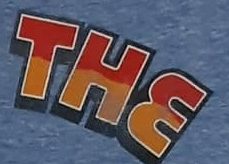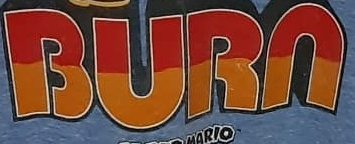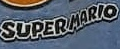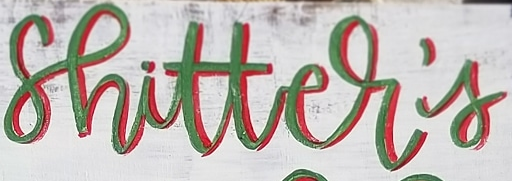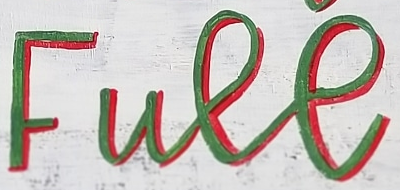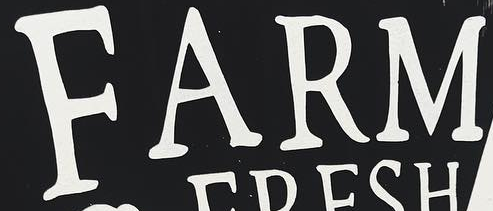Identify the words shown in these images in order, separated by a semicolon. THE; BURN; SUPERMARIO; shitter's; Full; FARM 